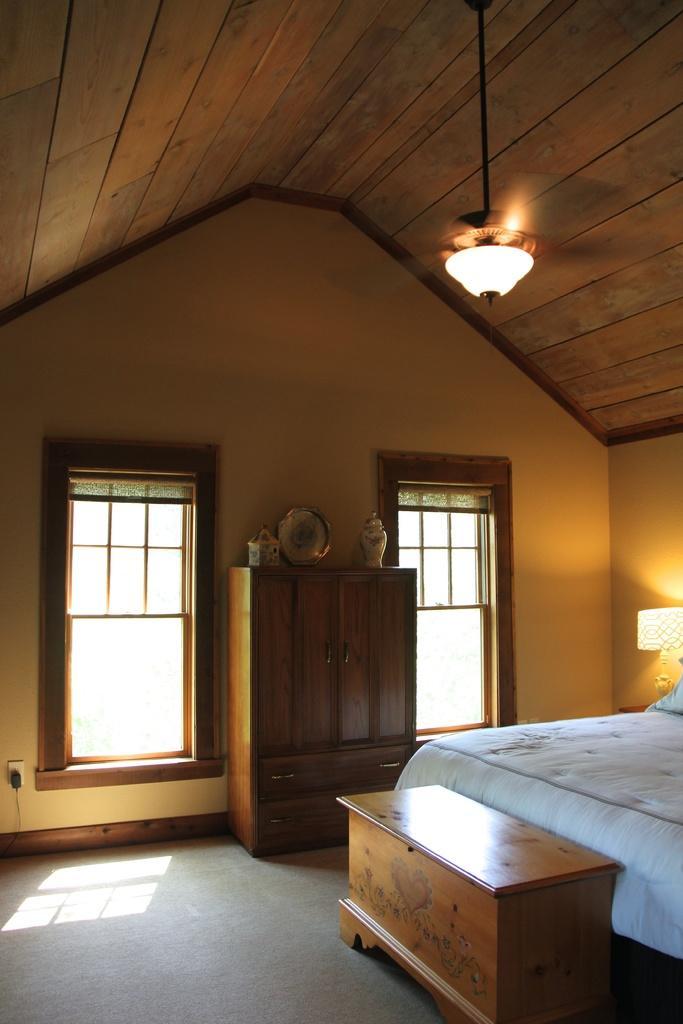How would you summarize this image in a sentence or two? In this image I can see a bed, a light, almirah and windows. 